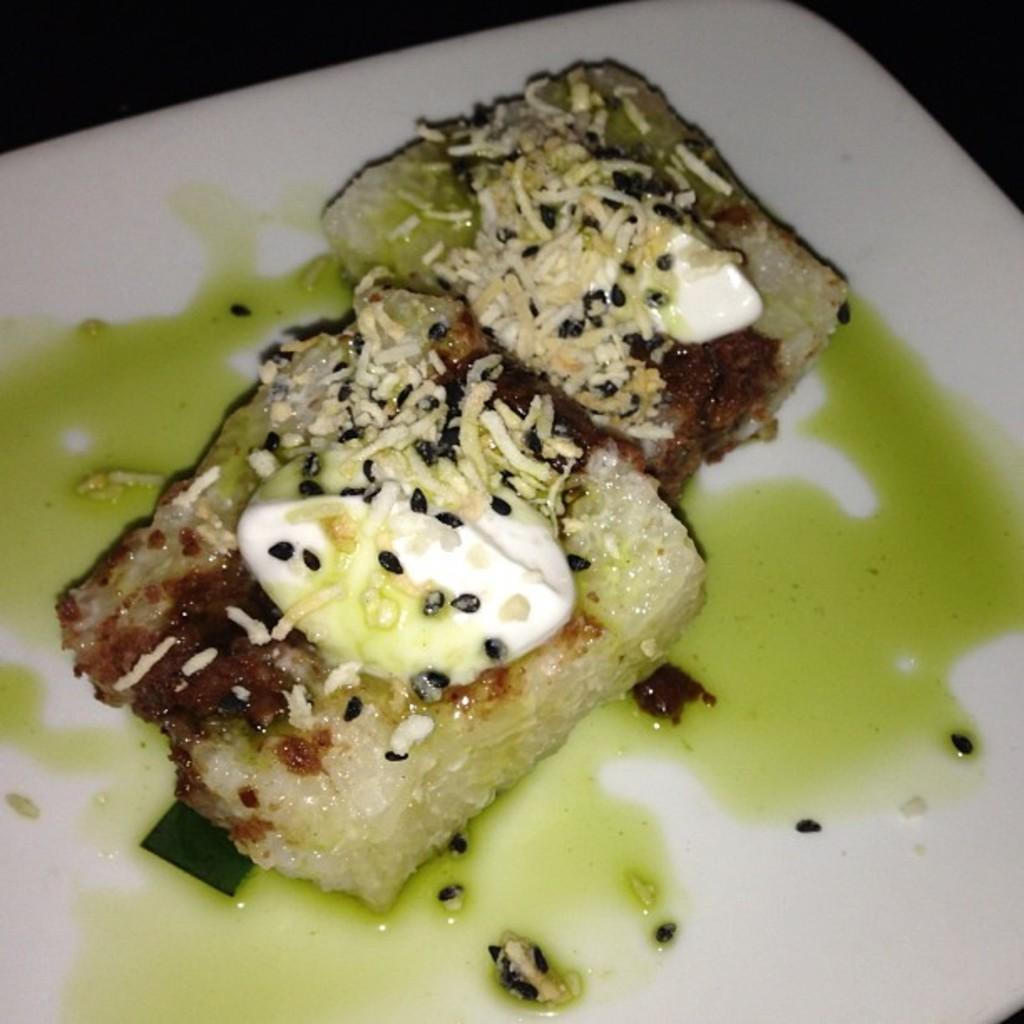What is on the plate in the image? There are food items on a plate in the image. What else can be seen on the plate besides the food items? There is liquid on the plate in the image. What color is the plate? The plate is white in color. How much snow is visible on the side of the plate in the image? There is no snow visible on the side of the plate in the image, as it is a plate with food items and liquid. 